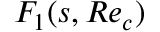Convert formula to latex. <formula><loc_0><loc_0><loc_500><loc_500>F _ { 1 } ( s , R e _ { c } )</formula> 